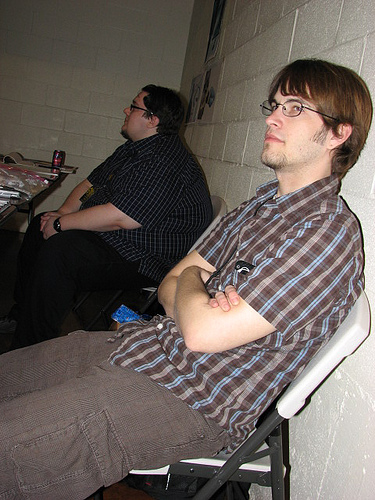<image>
Is there a man on the chair? Yes. Looking at the image, I can see the man is positioned on top of the chair, with the chair providing support. Where is the pants in relation to the picture? Is it under the picture? No. The pants is not positioned under the picture. The vertical relationship between these objects is different. Is there a man in the chair? No. The man is not contained within the chair. These objects have a different spatial relationship. 